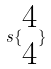<formula> <loc_0><loc_0><loc_500><loc_500>s \{ \begin{matrix} 4 \\ 4 \end{matrix} \}</formula> 